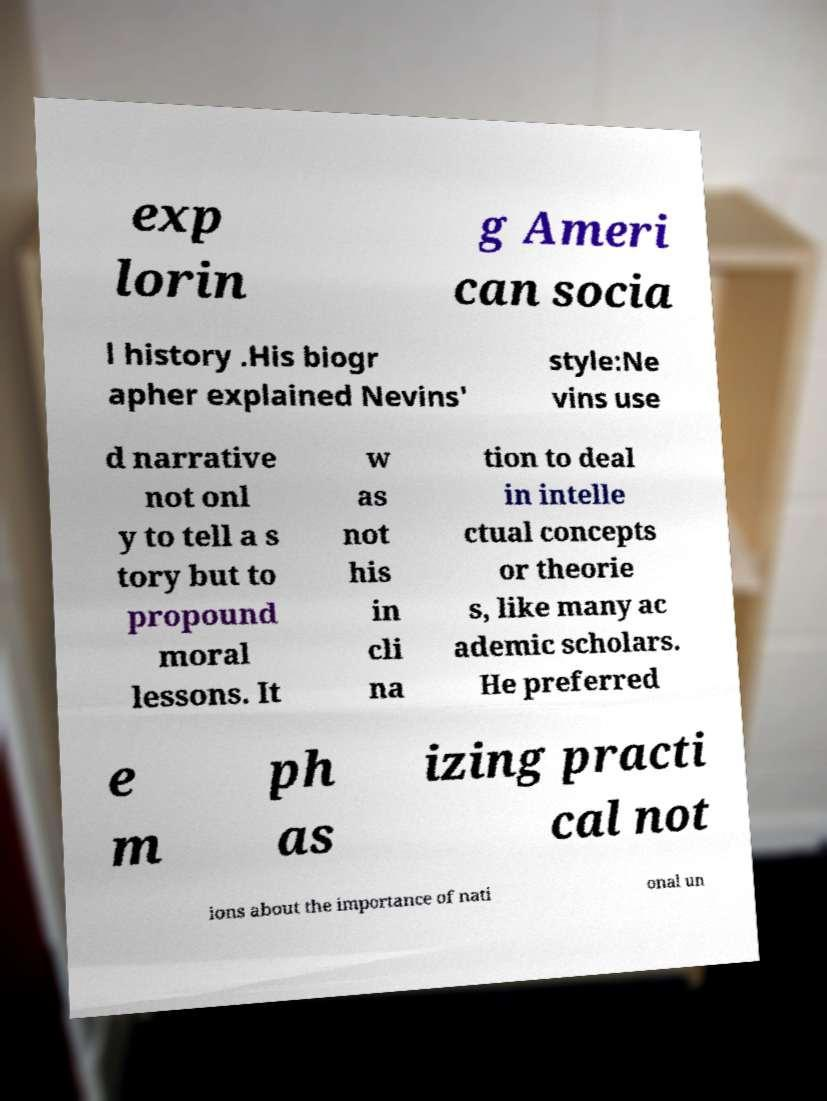Can you read and provide the text displayed in the image?This photo seems to have some interesting text. Can you extract and type it out for me? exp lorin g Ameri can socia l history .His biogr apher explained Nevins' style:Ne vins use d narrative not onl y to tell a s tory but to propound moral lessons. It w as not his in cli na tion to deal in intelle ctual concepts or theorie s, like many ac ademic scholars. He preferred e m ph as izing practi cal not ions about the importance of nati onal un 